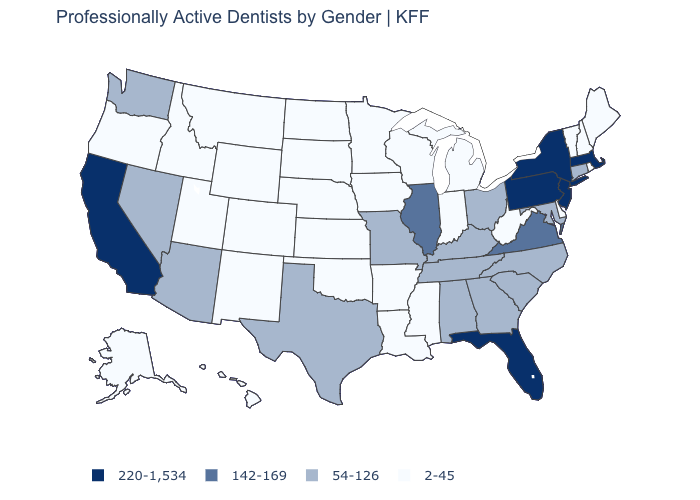Name the states that have a value in the range 220-1,534?
Be succinct. California, Florida, Massachusetts, New Jersey, New York, Pennsylvania. What is the value of Maryland?
Quick response, please. 54-126. What is the value of Arizona?
Keep it brief. 54-126. Name the states that have a value in the range 2-45?
Quick response, please. Alaska, Arkansas, Colorado, Delaware, Hawaii, Idaho, Indiana, Iowa, Kansas, Louisiana, Maine, Michigan, Minnesota, Mississippi, Montana, Nebraska, New Hampshire, New Mexico, North Dakota, Oklahoma, Oregon, Rhode Island, South Dakota, Utah, Vermont, West Virginia, Wisconsin, Wyoming. What is the lowest value in states that border Maryland?
Be succinct. 2-45. What is the value of Ohio?
Keep it brief. 54-126. What is the value of Florida?
Give a very brief answer. 220-1,534. Name the states that have a value in the range 54-126?
Write a very short answer. Alabama, Arizona, Connecticut, Georgia, Kentucky, Maryland, Missouri, Nevada, North Carolina, Ohio, South Carolina, Tennessee, Texas, Washington. What is the value of Maryland?
Answer briefly. 54-126. Name the states that have a value in the range 54-126?
Answer briefly. Alabama, Arizona, Connecticut, Georgia, Kentucky, Maryland, Missouri, Nevada, North Carolina, Ohio, South Carolina, Tennessee, Texas, Washington. Among the states that border Texas , which have the lowest value?
Keep it brief. Arkansas, Louisiana, New Mexico, Oklahoma. What is the lowest value in states that border Georgia?
Give a very brief answer. 54-126. Does New York have the highest value in the USA?
Answer briefly. Yes. Does Rhode Island have the lowest value in the Northeast?
Give a very brief answer. Yes. 